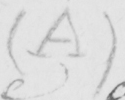Can you tell me what this handwritten text says? ( A ) 